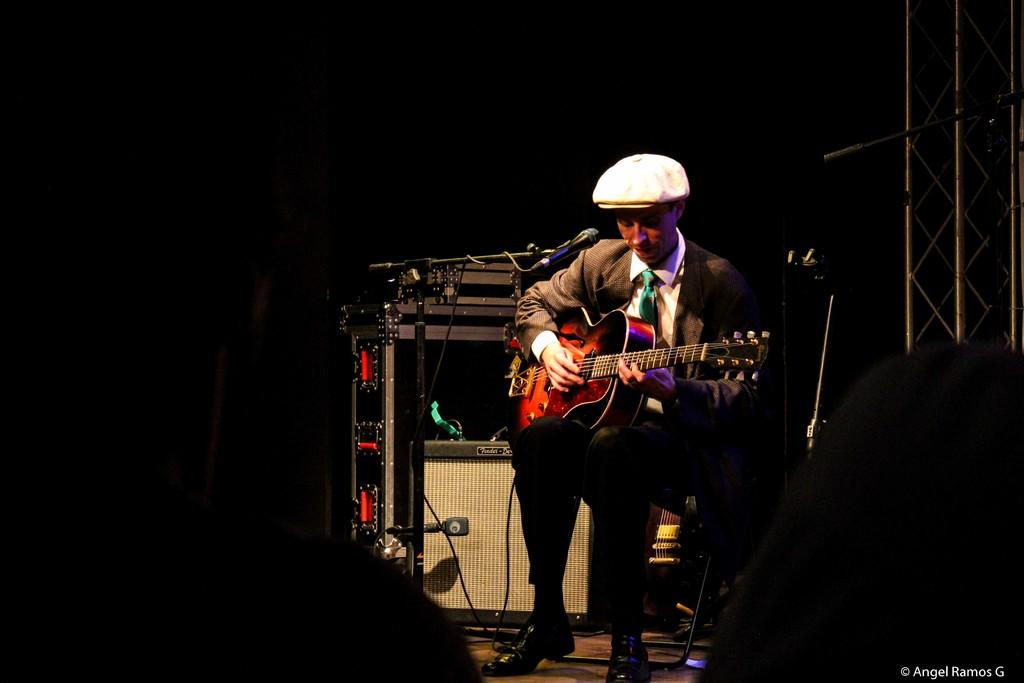What is the person in the image doing? The person is sitting on a chair and playing a guitar. Can you describe the person's attire? The person is wearing a cap. What equipment is present in the image for amplifying sound? There are microphones with stands in the image. What can be seen in the background of the image? There is an electrical device and a rod visible in the background. How many trucks are visible in the image? There are no trucks present in the image. What type of gold object can be seen in the background? There is no gold object present in the image. 